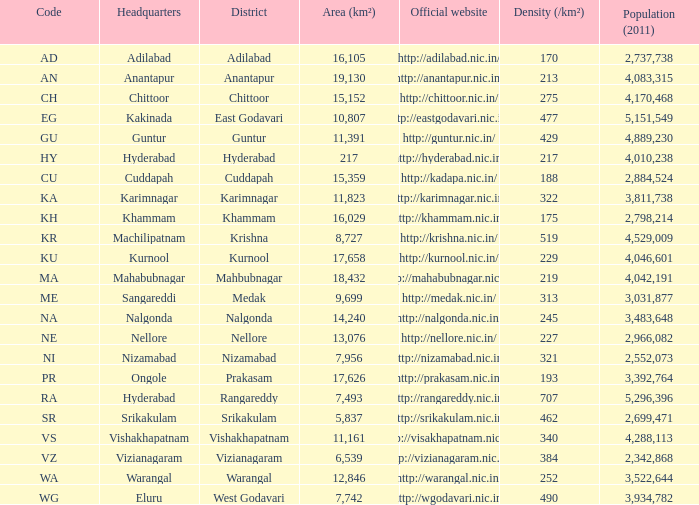What is the sum of the area values for districts having density over 462 and websites of http://krishna.nic.in/? 8727.0. 